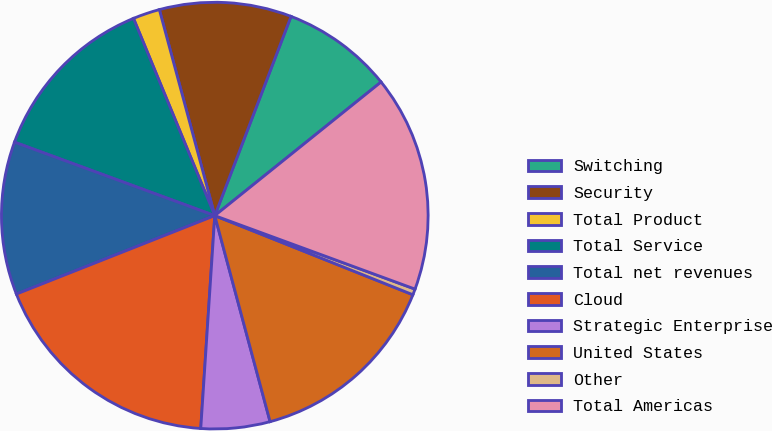Convert chart to OTSL. <chart><loc_0><loc_0><loc_500><loc_500><pie_chart><fcel>Switching<fcel>Security<fcel>Total Product<fcel>Total Service<fcel>Total net revenues<fcel>Cloud<fcel>Strategic Enterprise<fcel>United States<fcel>Other<fcel>Total Americas<nl><fcel>8.41%<fcel>10.0%<fcel>2.04%<fcel>13.18%<fcel>11.59%<fcel>17.96%<fcel>5.22%<fcel>14.78%<fcel>0.45%<fcel>16.37%<nl></chart> 